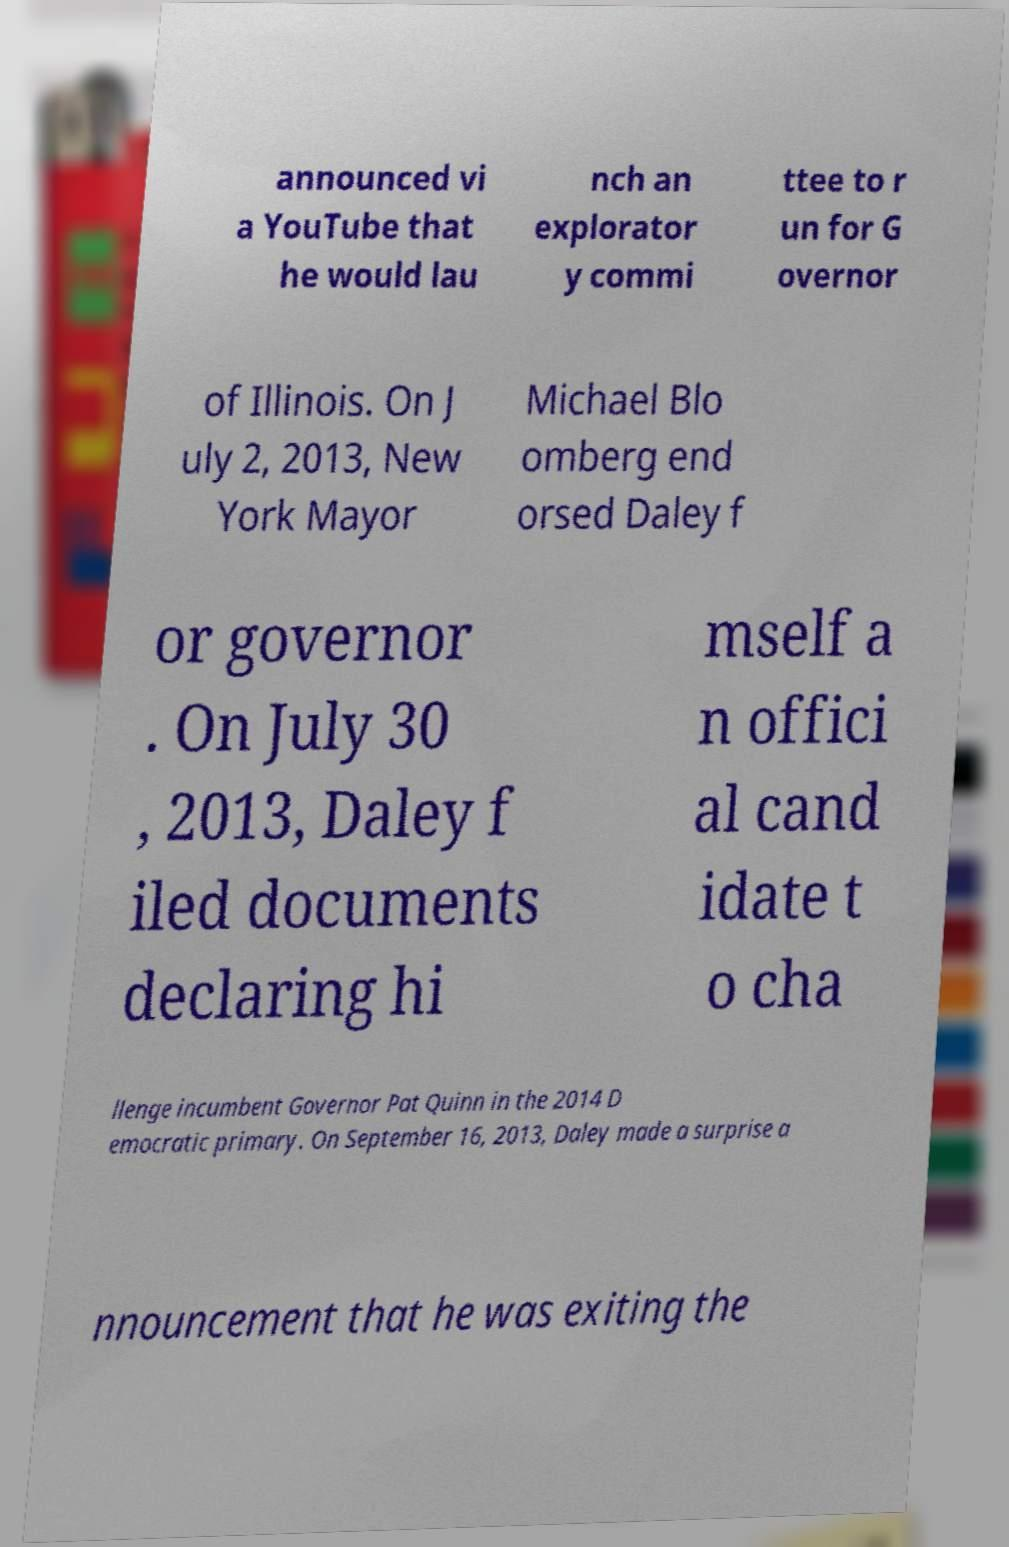Can you accurately transcribe the text from the provided image for me? announced vi a YouTube that he would lau nch an explorator y commi ttee to r un for G overnor of Illinois. On J uly 2, 2013, New York Mayor Michael Blo omberg end orsed Daley f or governor . On July 30 , 2013, Daley f iled documents declaring hi mself a n offici al cand idate t o cha llenge incumbent Governor Pat Quinn in the 2014 D emocratic primary. On September 16, 2013, Daley made a surprise a nnouncement that he was exiting the 